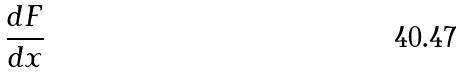Convert formula to latex. <formula><loc_0><loc_0><loc_500><loc_500>\frac { d F } { d x }</formula> 